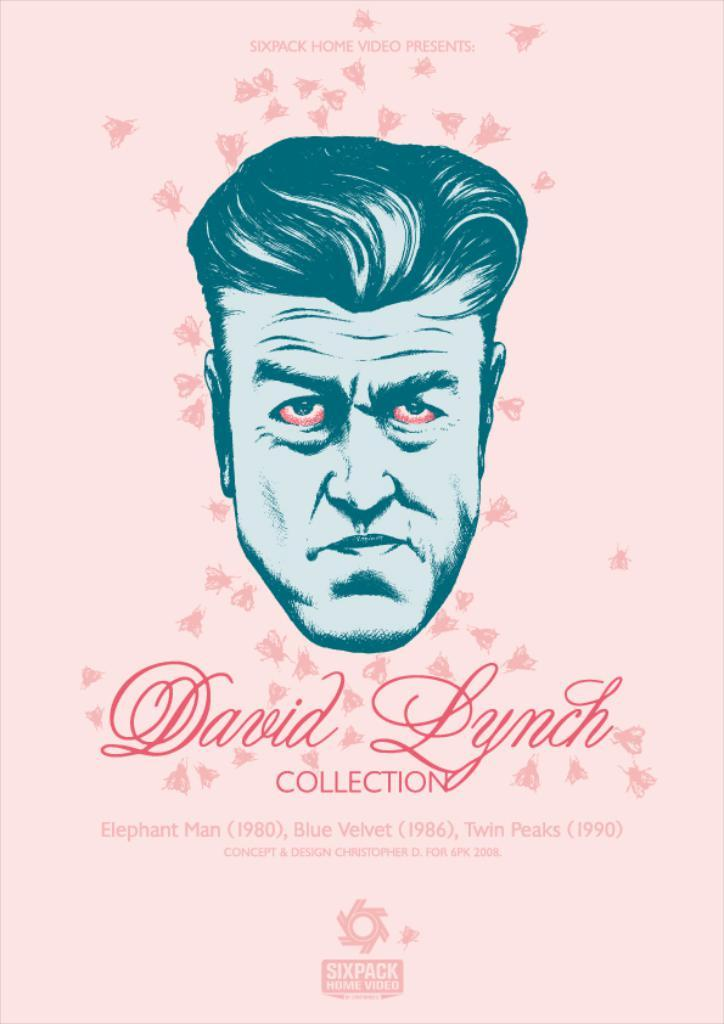What part of a person can be seen in the image? A person's head is visible in the image. What color is the paper that is visible in the image? There is a pink-colored paper in the image. What is written on the pink-colored paper? There is text written on the pink-colored paper. What type of drink is being consumed by the person in the image? There is no drink visible in the image; only the person's head and the pink-colored paper are present. What type of voyage is the person in the image planning? There is no indication of a voyage in the image; it only shows a person's head and a pink-colored paper with text on it. 